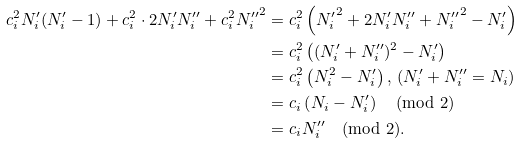Convert formula to latex. <formula><loc_0><loc_0><loc_500><loc_500>c _ { i } ^ { 2 } N _ { i } ^ { \prime } ( N _ { i } ^ { \prime } - 1 ) + c _ { i } ^ { 2 } \cdot 2 N _ { i } ^ { \prime } N _ { i } ^ { \prime \prime } + c _ { i } ^ { 2 } { N _ { i } ^ { \prime \prime } } ^ { 2 } & = c _ { i } ^ { 2 } \left ( { N _ { i } ^ { \prime } } ^ { 2 } + 2 N _ { i } ^ { \prime } N _ { i } ^ { \prime \prime } + { N _ { i } ^ { \prime \prime } } ^ { 2 } - N _ { i } ^ { \prime } \right ) \\ & = c _ { i } ^ { 2 } \left ( ( N _ { i } ^ { \prime } + N _ { i } ^ { \prime \prime } ) ^ { 2 } - N _ { i } ^ { \prime } \right ) \\ & = c _ { i } ^ { 2 } \left ( N _ { i } ^ { 2 } - N _ { i } ^ { \prime } \right ) , \, ( N _ { i } ^ { \prime } + N _ { i } ^ { \prime \prime } = N _ { i } ) \\ & = c _ { i } \left ( N _ { i } - N _ { i } ^ { \prime } \right ) \pmod { 2 } \\ & = c _ { i } N _ { i } ^ { \prime \prime } \pmod { 2 } . \\</formula> 